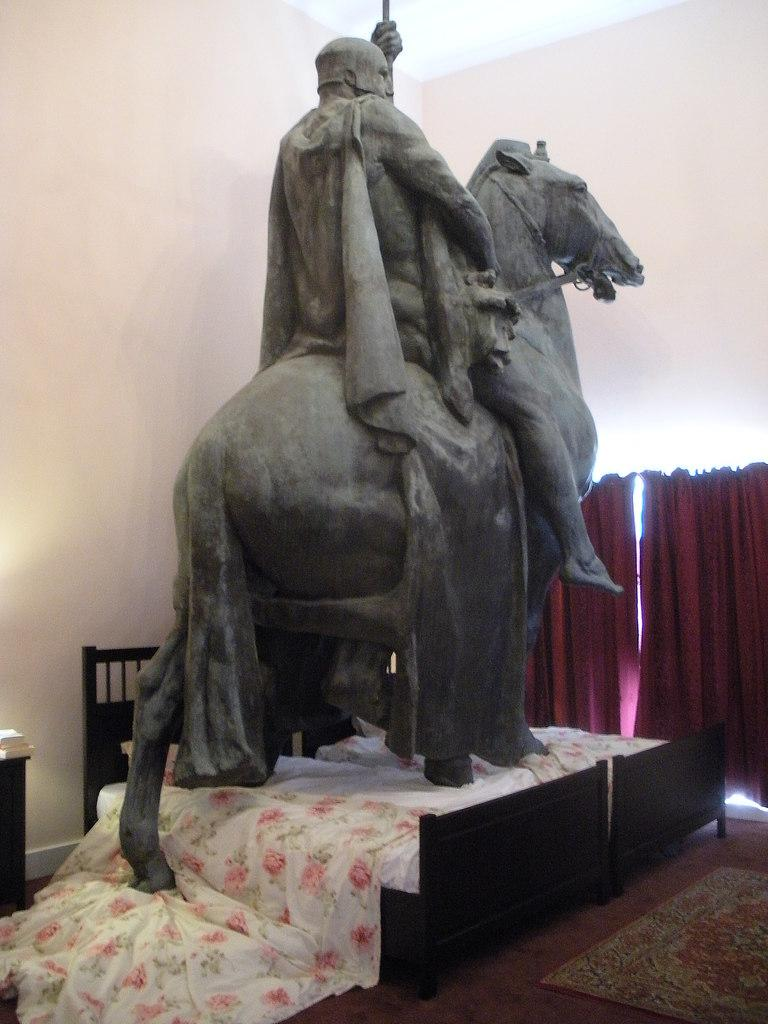What is the main subject in the image? There is a statue in the image. Where is the statue located? The statue is on a bed. What can be seen in the background of the image? There is a wall in the image. Are there any window treatments visible in the image? Yes, there is a curtain in the image. What type of coil is being used by the fireman in the image? There is no fireman or coil present in the image; it features a statue on a bed with a wall and a curtain in the background. 